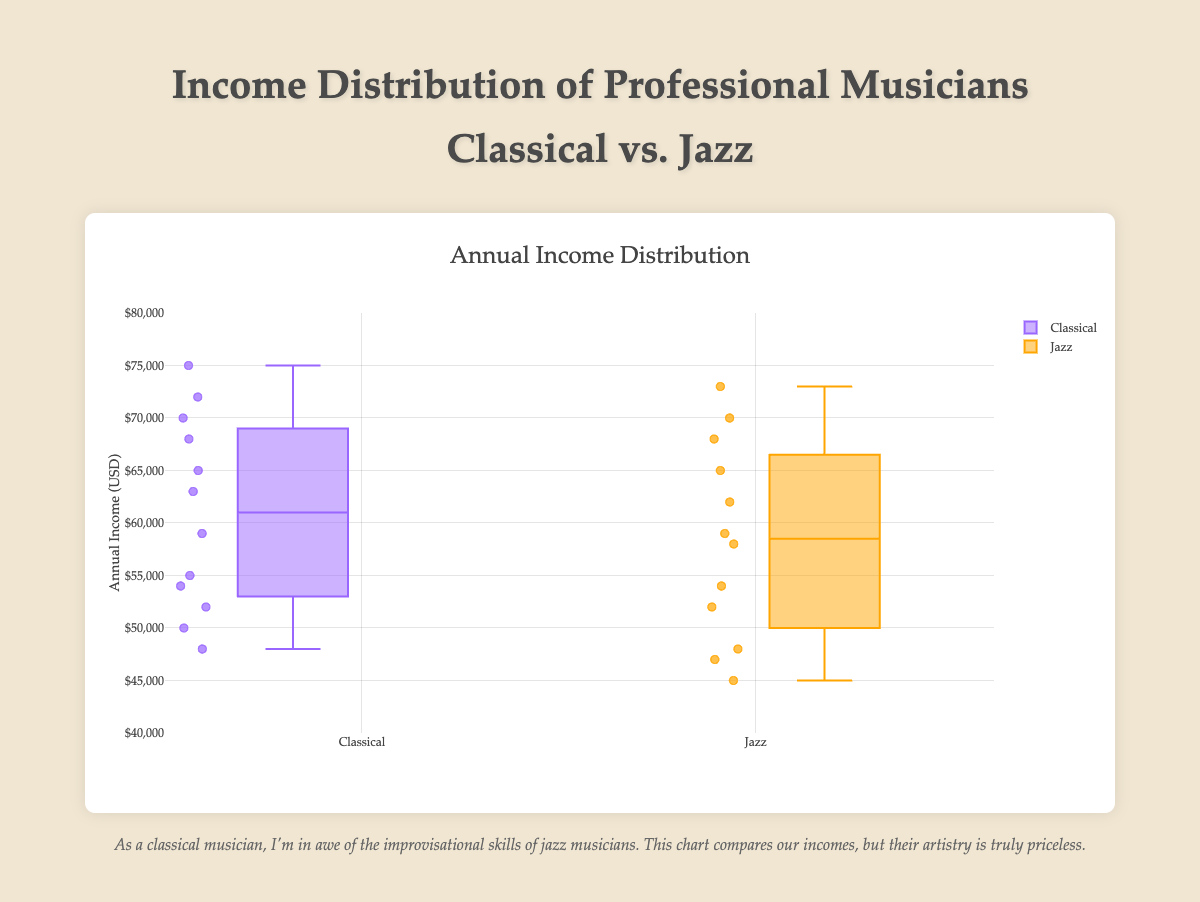What is the title of the box plot? The title of the box plot is written at the top of the chart. It is "Annual Income Distribution" as mentioned in the provided code.
Answer: Annual Income Distribution What genre has the highest median income? By examining the central line within each box, the median income can be observed. For Classical, the median appears higher than Jazz.
Answer: Classical What is the range of incomes for classical musicians? The range is determined by the difference between the maximum and minimum values within the box plot for the classical genre. According to the axis, these values lie between the whiskers of the classical box.
Answer: Between $48,000 and $75,000 Are there any outliers in the jazz category? Outliers in a box plot are shown as individual data points outside the whiskers. In the jazz category, if there are no individual points outside the whiskers, then there are no outliers.
Answer: No Which genre shows greater income variability? Greater variability is indicated by a wider interquartile range (IQR) in the box plot. By comparing the length of the boxes, jazz has a slightly larger spread.
Answer: Jazz Who earns more on average, classical or jazz musicians? Calculate the average of each genre. Sum the incomes and divide by the number of musicians. Classical: (50000 + 65000 + 72000 + 55000 + 48000 + 63000 + 70000 + 54000 + 59000 + 68000 + 75000 + 52000) / 12 = 61000. Jazz: (45000 + 62000 + 70000 + 47000 + 52000 + 68000 + 59000 + 48000 + 54000 + 65000 + 73000 + 58000) / 12 = 58833.33. Classical musicians earn more on average.
Answer: Classical How many data points are there for each genre? Count the individual incomes listed for each genre. Classical has 12 data points and jazz also has 12 data points.
Answer: 12 for each genre What is the minimum income for jazz musicians? The minimum income is represented by the bottom whisker of the jazz box plot. The bottom whisker of jazz touches $45,000.
Answer: $45,000 Is the third quartile (Q3) higher for classical or jazz musicians? The third quartile is the upper edge of the box. Compare the heights of the boxes at their upper edges. The classical box is taller at Q3.
Answer: Classical What is the interquartile range (IQR) for classical musicians? The IQR is calculated as Q3 - Q1, where Q3 is the upper edge and Q1 is the lower edge. For classical, these appear to approximate $70000 (Q3) and $54000 (Q1), so IQR = 70000 - 54000 = 16000.
Answer: 16000 